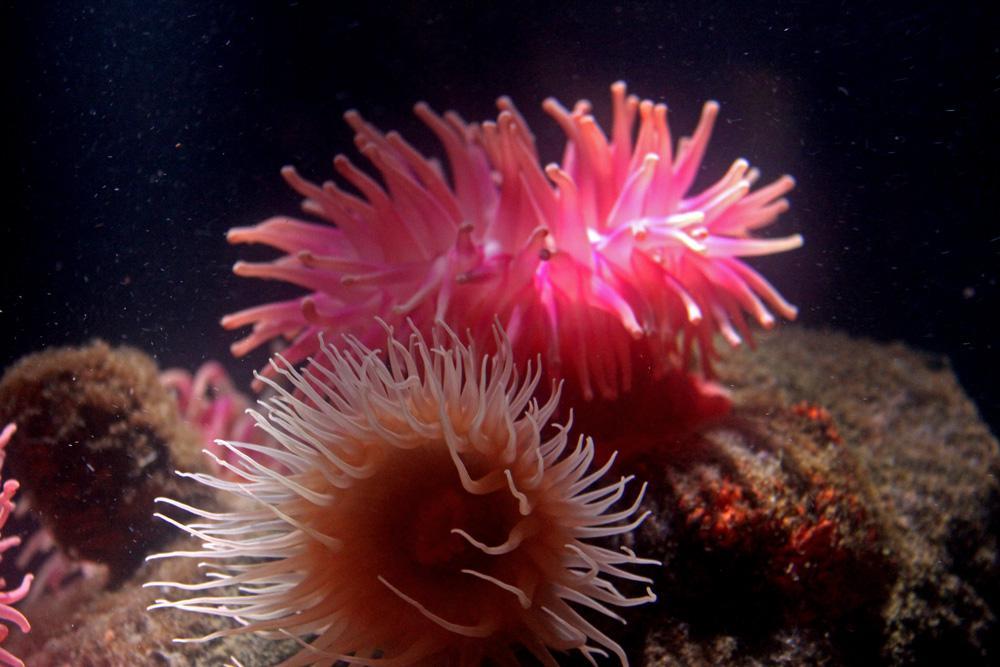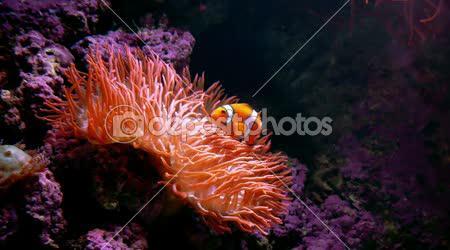The first image is the image on the left, the second image is the image on the right. Assess this claim about the two images: "There are at least two creatures in the image on the left.". Correct or not? Answer yes or no. Yes. 